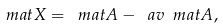Convert formula to latex. <formula><loc_0><loc_0><loc_500><loc_500>\ m a t { X } = \ m a t { A } - \ a v { \ m a t { A } } ,</formula> 